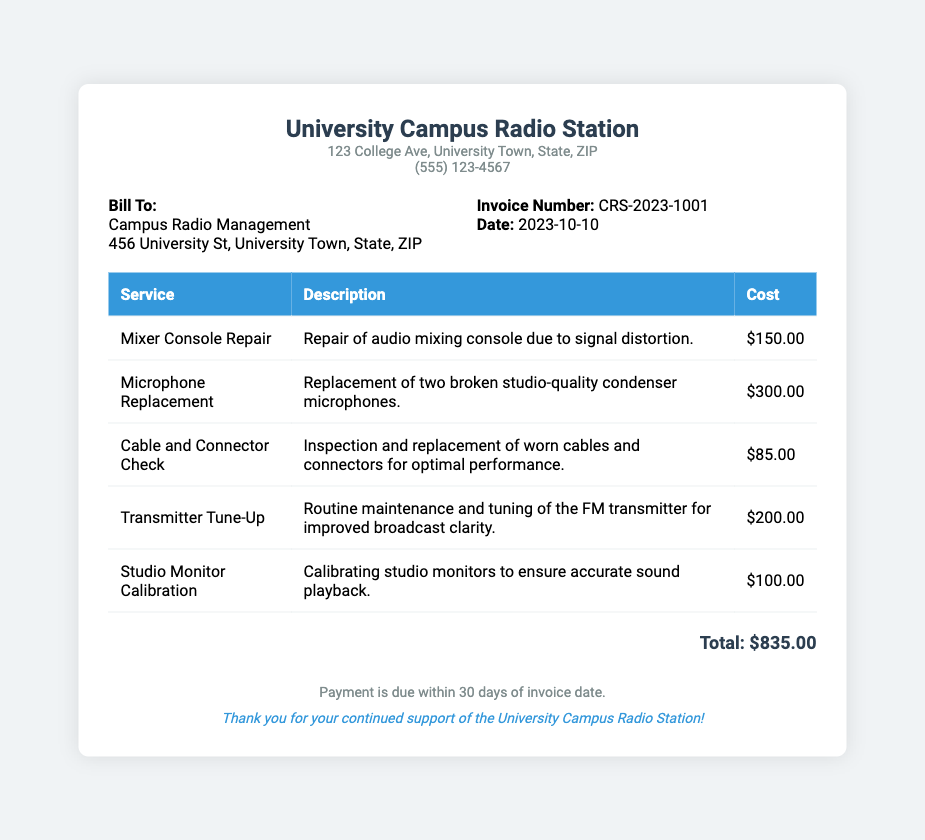What is the invoice number? The invoice number is a unique identifier for the bill provided in the document, which is CRS-2023-1001.
Answer: CRS-2023-1001 What is the total cost for repairs? The total cost for repairs is calculated by summing the costs of all services listed in the document, which totals $835.00.
Answer: $835.00 Who is the bill addressed to? The bill is addressed to the entity responsible for the payments mentioned in the document, which is Campus Radio Management.
Answer: Campus Radio Management What date is the invoice issued? The invoice date indicates when the bill was created, which is listed as 2023-10-10.
Answer: 2023-10-10 How much does the microphone replacement cost? The cost for the microphone replacement service is clearly stated in the document as $300.00.
Answer: $300.00 What service requires repair due to signal distortion? Signal distortion is mentioned as a reason for repair in the service description for the mixer console.
Answer: Mixer Console Repair How many condenser microphones were replaced? The document specifies that two broken studio-quality condenser microphones were replaced.
Answer: Two What is the description of the Transmitter Tune-Up service? The description outlines the routine nature of the service aimed at improving broadcast clarity, making it identified in the document.
Answer: Routine maintenance and tuning of the FM transmitter for improved broadcast clarity What payment terms are mentioned in the bill? The payment terms detail when payment is due, which is stated in the document as within 30 days of the invoice date.
Answer: Within 30 days of invoice date 